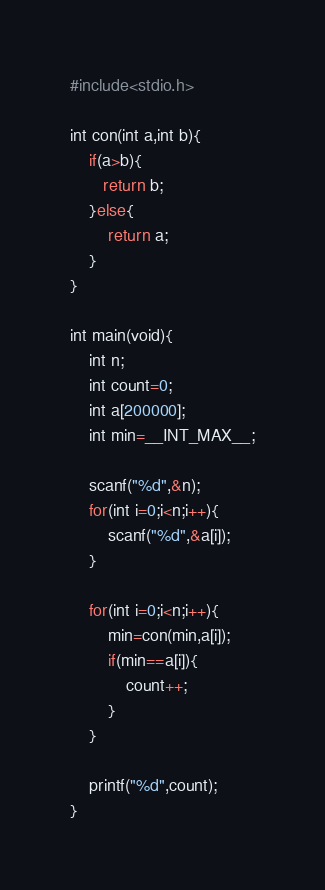<code> <loc_0><loc_0><loc_500><loc_500><_Python_>#include<stdio.h>

int con(int a,int b){
    if(a>b){
       return b; 
    }else{
        return a;
    }
}

int main(void){
    int n;
    int count=0;
    int a[200000];
    int min=__INT_MAX__;

    scanf("%d",&n);
    for(int i=0;i<n;i++){
        scanf("%d",&a[i]);
    }

    for(int i=0;i<n;i++){
        min=con(min,a[i]);
        if(min==a[i]){
            count++;
        }
    }

    printf("%d",count);
}</code> 